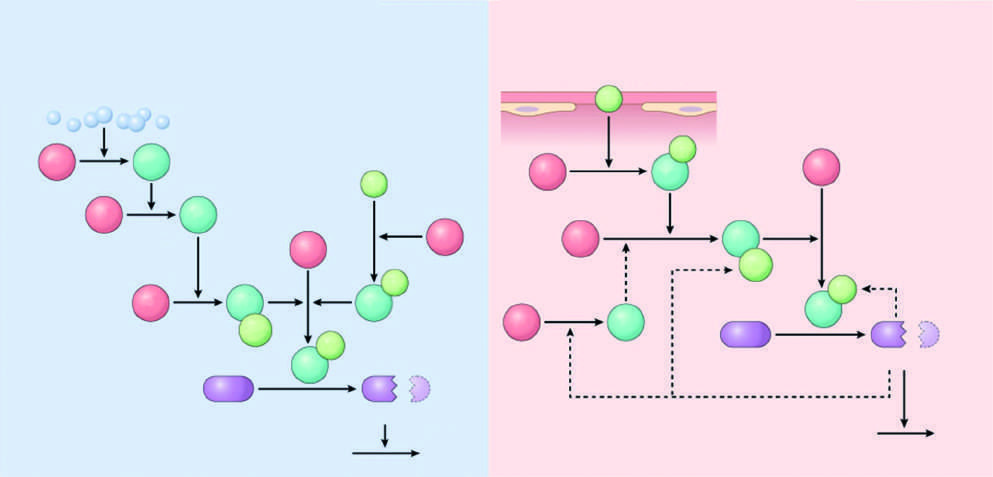s the major initiator of coagulation amplified by feedback loops involving thrombin?
Answer the question using a single word or phrase. Yes 